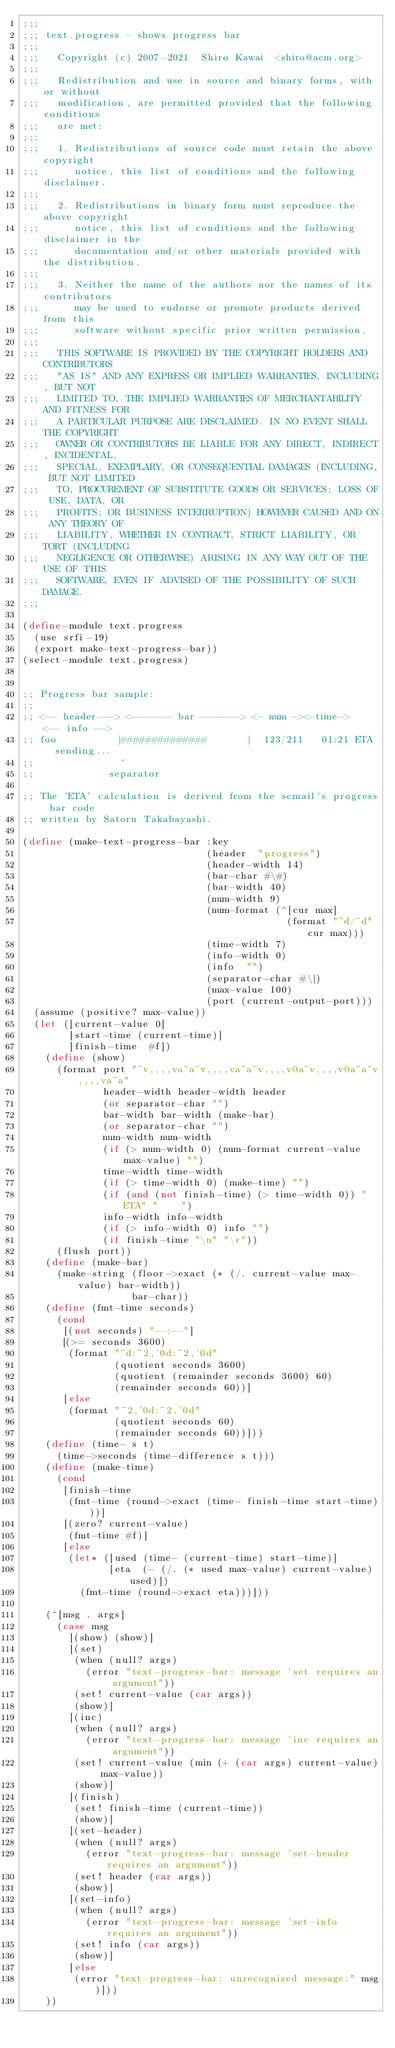<code> <loc_0><loc_0><loc_500><loc_500><_Scheme_>;;;
;;; text.progress - shows progress bar
;;;
;;;   Copyright (c) 2007-2021  Shiro Kawai  <shiro@acm.org>
;;;
;;;   Redistribution and use in source and binary forms, with or without
;;;   modification, are permitted provided that the following conditions
;;;   are met:
;;;
;;;   1. Redistributions of source code must retain the above copyright
;;;      notice, this list of conditions and the following disclaimer.
;;;
;;;   2. Redistributions in binary form must reproduce the above copyright
;;;      notice, this list of conditions and the following disclaimer in the
;;;      documentation and/or other materials provided with the distribution.
;;;
;;;   3. Neither the name of the authors nor the names of its contributors
;;;      may be used to endorse or promote products derived from this
;;;      software without specific prior written permission.
;;;
;;;   THIS SOFTWARE IS PROVIDED BY THE COPYRIGHT HOLDERS AND CONTRIBUTORS
;;;   "AS IS" AND ANY EXPRESS OR IMPLIED WARRANTIES, INCLUDING, BUT NOT
;;;   LIMITED TO, THE IMPLIED WARRANTIES OF MERCHANTABILITY AND FITNESS FOR
;;;   A PARTICULAR PURPOSE ARE DISCLAIMED. IN NO EVENT SHALL THE COPYRIGHT
;;;   OWNER OR CONTRIBUTORS BE LIABLE FOR ANY DIRECT, INDIRECT, INCIDENTAL,
;;;   SPECIAL, EXEMPLARY, OR CONSEQUENTIAL DAMAGES (INCLUDING, BUT NOT LIMITED
;;;   TO, PROCUREMENT OF SUBSTITUTE GOODS OR SERVICES; LOSS OF USE, DATA, OR
;;;   PROFITS; OR BUSINESS INTERRUPTION) HOWEVER CAUSED AND ON ANY THEORY OF
;;;   LIABILITY, WHETHER IN CONTRACT, STRICT LIABILITY, OR TORT (INCLUDING
;;;   NEGLIGENCE OR OTHERWISE) ARISING IN ANY WAY OUT OF THE USE OF THIS
;;;   SOFTWARE, EVEN IF ADVISED OF THE POSSIBILITY OF SUCH DAMAGE.
;;;

(define-module text.progress
  (use srfi-19)
  (export make-text-progress-bar))
(select-module text.progress)


;; Progress bar sample:
;;
;; <-- header---> <------- bar -------> <- num -><-time->     <-- info -->
;; foo           |##############       |  123/211   01:21 ETA   sending...
;;               ^
;;             separator

;; The 'ETA' calculation is derived from the scmail's progress bar code
;; written by Satoru Takabayashi.

(define (make-text-progress-bar :key
                                (header  "progress")
                                (header-width 14)
                                (bar-char #\#)
                                (bar-width 40)
                                (num-width 9)
                                (num-format (^[cur max]
                                              (format "~d/~d" cur max)))
                                (time-width 7)
                                (info-width 0)
                                (info  "")
                                (separator-char #\|)
                                (max-value 100)
                                (port (current-output-port)))
  (assume (positive? max-value))
  (let ([current-value 0]
        [start-time (current-time)]
        [finish-time  #f])
    (define (show)
      (format port "~v,,,,va~a~v,,,,va~a~v,,,,v@a~v,,,,v@a~a~v,,,,va~a"
              header-width header-width header
              (or separator-char "")
              bar-width bar-width (make-bar)
              (or separator-char "")
              num-width num-width
              (if (> num-width 0) (num-format current-value max-value) "")
              time-width time-width
              (if (> time-width 0) (make-time) "")
              (if (and (not finish-time) (> time-width 0)) " ETA" "    ")
              info-width info-width
              (if (> info-width 0) info "")
              (if finish-time "\n" "\r"))
      (flush port))
    (define (make-bar)
      (make-string (floor->exact (* (/. current-value max-value) bar-width))
                   bar-char))
    (define (fmt-time seconds)
      (cond
       [(not seconds) "--:--"]
       [(>= seconds 3600)
        (format "~d:~2,'0d:~2,'0d"
                (quotient seconds 3600)
                (quotient (remainder seconds 3600) 60)
                (remainder seconds 60))]
       [else
        (format "~2,'0d:~2,'0d"
                (quotient seconds 60)
                (remainder seconds 60))]))
    (define (time- s t)
      (time->seconds (time-difference s t)))
    (define (make-time)
      (cond
       [finish-time
        (fmt-time (round->exact (time- finish-time start-time)))]
       [(zero? current-value)
        (fmt-time #f)]
       [else
        (let* ([used (time- (current-time) start-time)]
               [eta  (- (/. (* used max-value) current-value) used)])
          (fmt-time (round->exact eta)))]))

    (^[msg . args]
      (case msg
        [(show) (show)]
        [(set)
         (when (null? args)
           (error "text-progress-bar: message 'set requires an argument"))
         (set! current-value (car args))
         (show)]
        [(inc)
         (when (null? args)
           (error "text-progress-bar: message 'inc requires an argument"))
         (set! current-value (min (+ (car args) current-value) max-value))
         (show)]
        [(finish)
         (set! finish-time (current-time))
         (show)]
        [(set-header)
         (when (null? args)
           (error "text-progress-bar: message 'set-header requires an argument"))
         (set! header (car args))
         (show)]
        [(set-info)
         (when (null? args)
           (error "text-progress-bar: message 'set-info requires an argument"))
         (set! info (car args))
         (show)]
        [else
         (error "text-progress-bar: unrecognized message:" msg)]))
    ))
</code> 